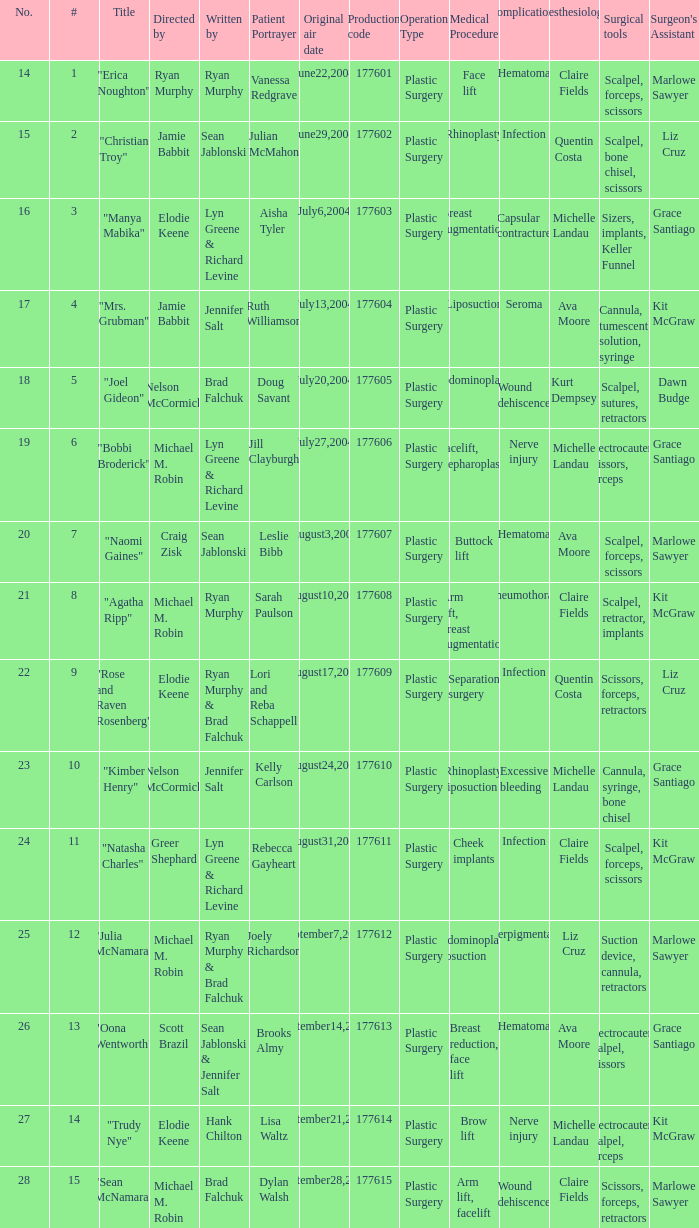Who wrote episode number 28? Brad Falchuk. I'm looking to parse the entire table for insights. Could you assist me with that? {'header': ['No.', '#', 'Title', 'Directed by', 'Written by', 'Patient Portrayer', 'Original air date', 'Production code', 'Operation Type', 'Medical Procedure', 'Complications', 'Anesthesiologist', 'Surgical tools', "Surgeon's Assistant"], 'rows': [['14', '1', '"Erica Noughton"', 'Ryan Murphy', 'Ryan Murphy', 'Vanessa Redgrave', 'June22,2004', '177601', 'Plastic Surgery', 'Face lift', 'Hematoma', 'Claire Fields', 'Scalpel, forceps, scissors', 'Marlowe Sawyer'], ['15', '2', '"Christian Troy"', 'Jamie Babbit', 'Sean Jablonski', 'Julian McMahon', 'June29,2004', '177602', 'Plastic Surgery', 'Rhinoplasty', 'Infection', 'Quentin Costa', 'Scalpel, bone chisel, scissors', 'Liz Cruz'], ['16', '3', '"Manya Mabika"', 'Elodie Keene', 'Lyn Greene & Richard Levine', 'Aisha Tyler', 'July6,2004', '177603', 'Plastic Surgery', 'Breast augmentation', 'Capsular contracture', 'Michelle Landau', 'Sizers, implants, Keller Funnel', 'Grace Santiago'], ['17', '4', '"Mrs. Grubman"', 'Jamie Babbit', 'Jennifer Salt', 'Ruth Williamson', 'July13,2004', '177604', 'Plastic Surgery', 'Liposuction', 'Seroma', 'Ava Moore', 'Cannula, tumescent solution, syringe', 'Kit McGraw'], ['18', '5', '"Joel Gideon"', 'Nelson McCormick', 'Brad Falchuk', 'Doug Savant', 'July20,2004', '177605', 'Plastic Surgery', 'Abdominoplasty', 'Wound dehiscence', 'Kurt Dempsey', 'Scalpel, sutures, retractors', 'Dawn Budge'], ['19', '6', '"Bobbi Broderick"', 'Michael M. Robin', 'Lyn Greene & Richard Levine', 'Jill Clayburgh', 'July27,2004', '177606', 'Plastic Surgery', 'Facelift, blepharoplasty', 'Nerve injury', 'Michelle Landau', 'Electrocautery, scissors, forceps', 'Grace Santiago'], ['20', '7', '"Naomi Gaines"', 'Craig Zisk', 'Sean Jablonski', 'Leslie Bibb', 'August3,2004', '177607', 'Plastic Surgery', 'Buttock lift', 'Hematoma', 'Ava Moore', 'Scalpel, forceps, scissors', 'Marlowe Sawyer'], ['21', '8', '"Agatha Ripp"', 'Michael M. Robin', 'Ryan Murphy', 'Sarah Paulson', 'August10,2004', '177608', 'Plastic Surgery', 'Arm lift, breast augmentation', 'Pneumothorax', 'Claire Fields', 'Scalpel, retractor, implants', 'Kit McGraw'], ['22', '9', '"Rose and Raven Rosenberg"', 'Elodie Keene', 'Ryan Murphy & Brad Falchuk', 'Lori and Reba Schappell', 'August17,2004', '177609', 'Plastic Surgery', 'Separation surgery', 'Infection', 'Quentin Costa', 'Scissors, forceps, retractors', 'Liz Cruz'], ['23', '10', '"Kimber Henry"', 'Nelson McCormick', 'Jennifer Salt', 'Kelly Carlson', 'August24,2004', '177610', 'Plastic Surgery', 'Rhinoplasty, liposuction', 'Excessive bleeding', 'Michelle Landau', 'Cannula, syringe, bone chisel', 'Grace Santiago'], ['24', '11', '"Natasha Charles"', 'Greer Shephard', 'Lyn Greene & Richard Levine', 'Rebecca Gayheart', 'August31,2004', '177611', 'Plastic Surgery', 'Cheek implants', 'Infection', 'Claire Fields', 'Scalpel, forceps, scissors', 'Kit McGraw'], ['25', '12', '"Julia McNamara"', 'Michael M. Robin', 'Ryan Murphy & Brad Falchuk', 'Joely Richardson', 'September7,2004', '177612', 'Plastic Surgery', 'Abdominoplasty, liposuction', 'Hyperpigmentation', 'Liz Cruz', 'Suction device, cannula, retractors', 'Marlowe Sawyer'], ['26', '13', '"Oona Wentworth"', 'Scott Brazil', 'Sean Jablonski & Jennifer Salt', 'Brooks Almy', 'September14,2004', '177613', 'Plastic Surgery', 'Breast reduction, face lift', 'Hematoma', 'Ava Moore', 'Electrocautery, scalpel, scissors', 'Grace Santiago'], ['27', '14', '"Trudy Nye"', 'Elodie Keene', 'Hank Chilton', 'Lisa Waltz', 'September21,2004', '177614', 'Plastic Surgery', 'Brow lift', 'Nerve injury', 'Michelle Landau', 'Electrocautery, scalpel, forceps', 'Kit McGraw'], ['28', '15', '"Sean McNamara"', 'Michael M. Robin', 'Brad Falchuk', 'Dylan Walsh', 'September28,2004', '177615', 'Plastic Surgery', 'Arm lift, facelift', 'Wound dehiscence', 'Claire Fields', 'Scissors, forceps, retractors', 'Marlowe Sawyer']]} 